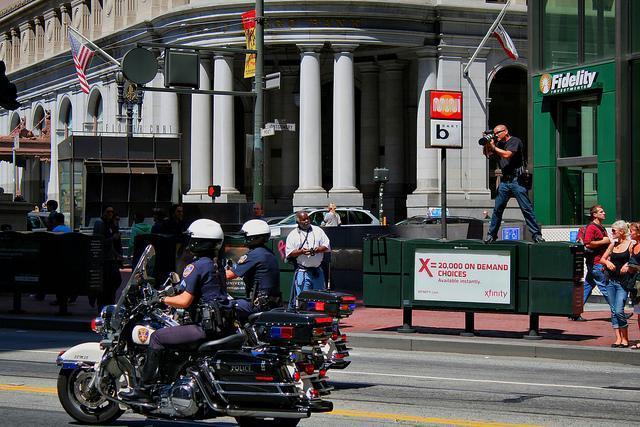How many people can you see?
Give a very brief answer. 6. 